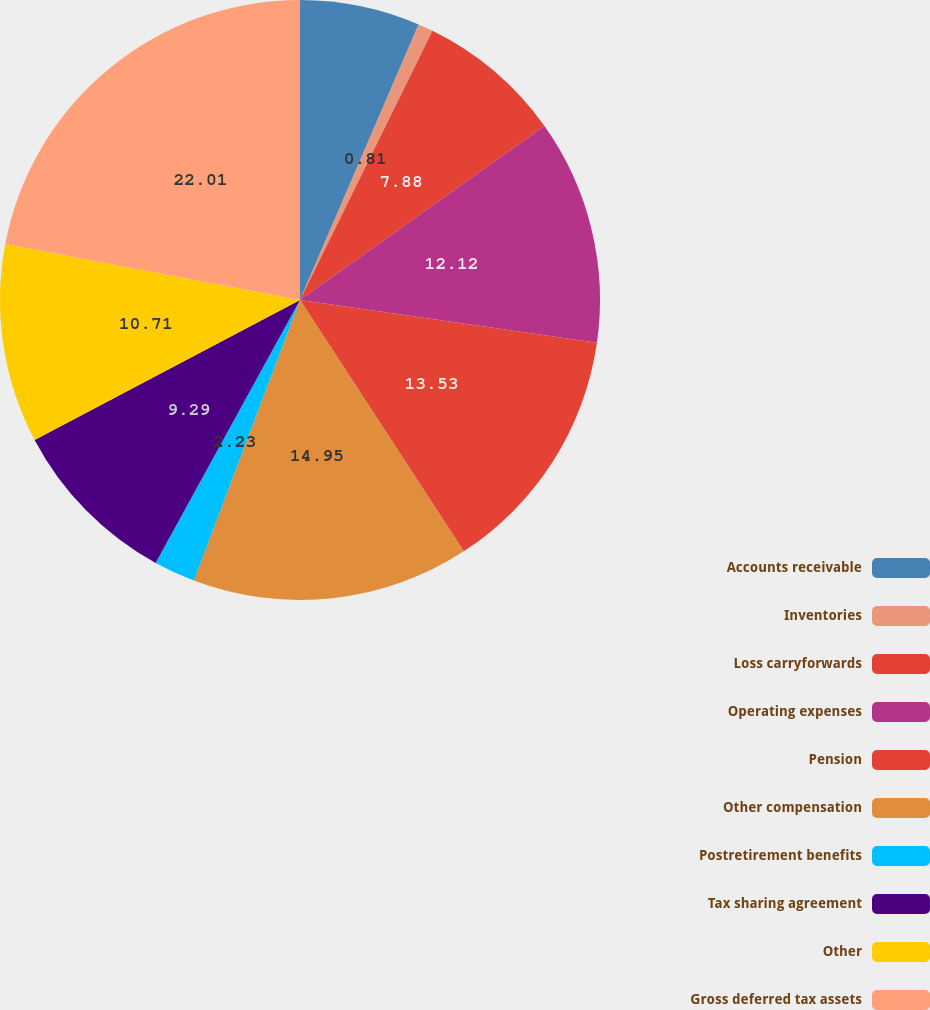Convert chart. <chart><loc_0><loc_0><loc_500><loc_500><pie_chart><fcel>Accounts receivable<fcel>Inventories<fcel>Loss carryforwards<fcel>Operating expenses<fcel>Pension<fcel>Other compensation<fcel>Postretirement benefits<fcel>Tax sharing agreement<fcel>Other<fcel>Gross deferred tax assets<nl><fcel>6.47%<fcel>0.81%<fcel>7.88%<fcel>12.12%<fcel>13.53%<fcel>14.95%<fcel>2.23%<fcel>9.29%<fcel>10.71%<fcel>22.01%<nl></chart> 